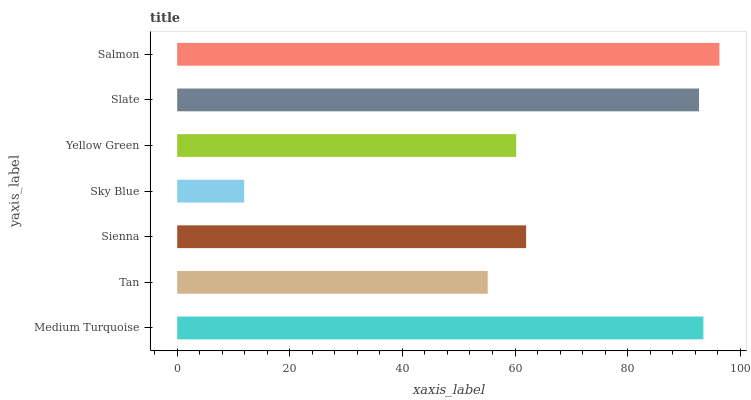Is Sky Blue the minimum?
Answer yes or no. Yes. Is Salmon the maximum?
Answer yes or no. Yes. Is Tan the minimum?
Answer yes or no. No. Is Tan the maximum?
Answer yes or no. No. Is Medium Turquoise greater than Tan?
Answer yes or no. Yes. Is Tan less than Medium Turquoise?
Answer yes or no. Yes. Is Tan greater than Medium Turquoise?
Answer yes or no. No. Is Medium Turquoise less than Tan?
Answer yes or no. No. Is Sienna the high median?
Answer yes or no. Yes. Is Sienna the low median?
Answer yes or no. Yes. Is Tan the high median?
Answer yes or no. No. Is Yellow Green the low median?
Answer yes or no. No. 